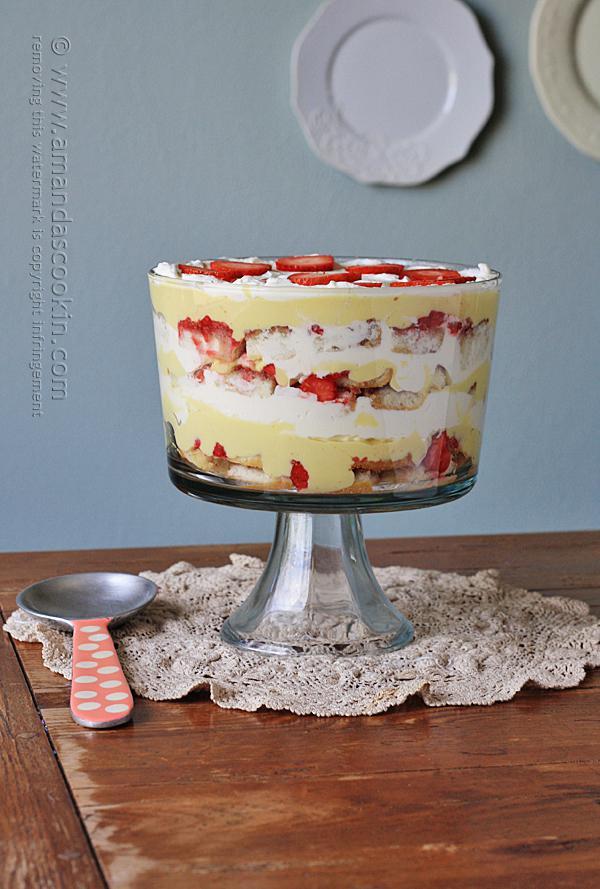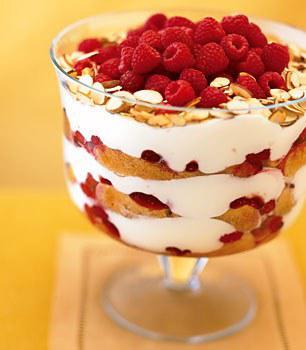The first image is the image on the left, the second image is the image on the right. Considering the images on both sides, is "A single dessert in the image on the left has a glass pedestal." valid? Answer yes or no. Yes. The first image is the image on the left, the second image is the image on the right. For the images displayed, is the sentence "One image shows a dessert topped with sliced, non-heaped strawberries, and the other shows a dessert topped with a different kind of small bright red fruit." factually correct? Answer yes or no. Yes. 